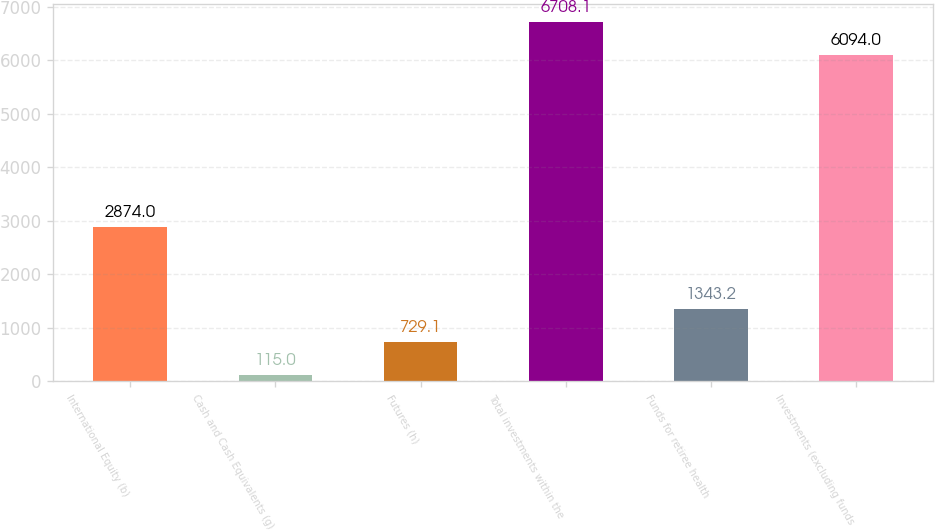<chart> <loc_0><loc_0><loc_500><loc_500><bar_chart><fcel>International Equity (b)<fcel>Cash and Cash Equivalents (g)<fcel>Futures (h)<fcel>Total investments within the<fcel>Funds for retiree health<fcel>Investments (excluding funds<nl><fcel>2874<fcel>115<fcel>729.1<fcel>6708.1<fcel>1343.2<fcel>6094<nl></chart> 